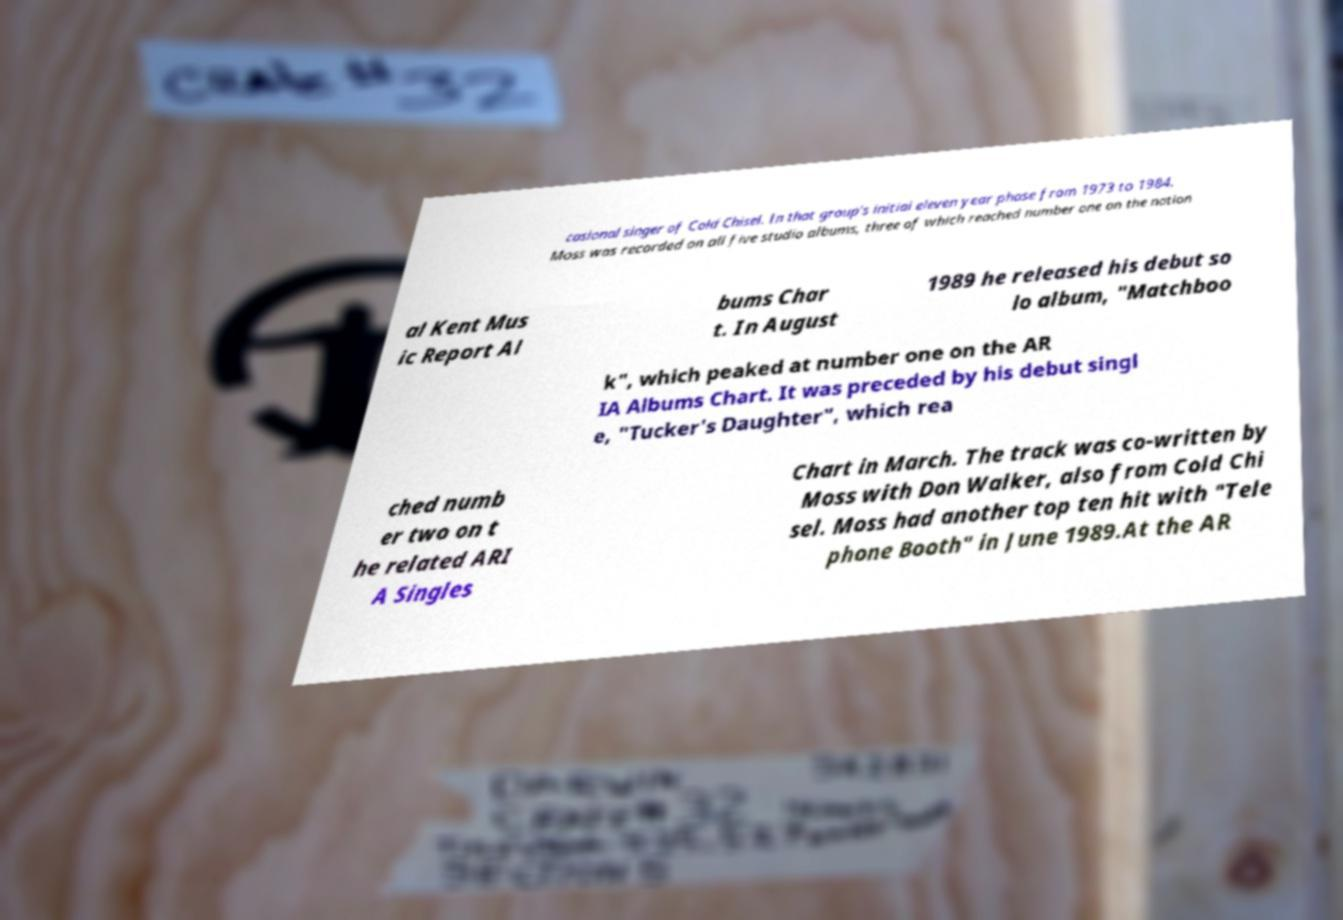For documentation purposes, I need the text within this image transcribed. Could you provide that? casional singer of Cold Chisel. In that group's initial eleven year phase from 1973 to 1984, Moss was recorded on all five studio albums, three of which reached number one on the nation al Kent Mus ic Report Al bums Char t. In August 1989 he released his debut so lo album, "Matchboo k", which peaked at number one on the AR IA Albums Chart. It was preceded by his debut singl e, "Tucker's Daughter", which rea ched numb er two on t he related ARI A Singles Chart in March. The track was co-written by Moss with Don Walker, also from Cold Chi sel. Moss had another top ten hit with "Tele phone Booth" in June 1989.At the AR 